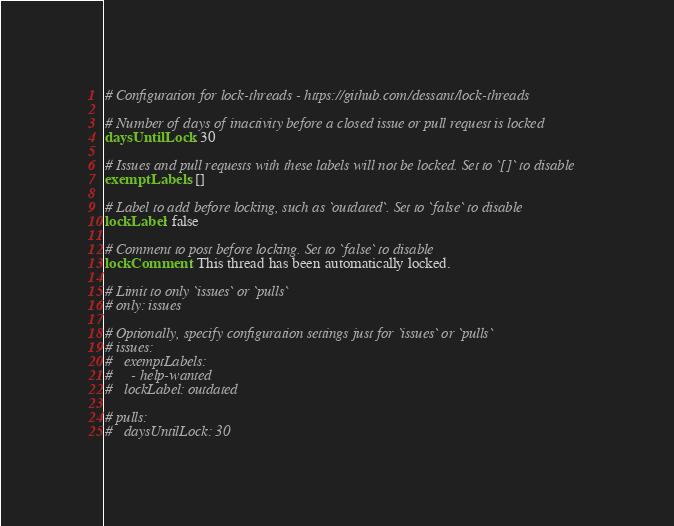Convert code to text. <code><loc_0><loc_0><loc_500><loc_500><_YAML_># Configuration for lock-threads - https://github.com/dessant/lock-threads

# Number of days of inactivity before a closed issue or pull request is locked
daysUntilLock: 30

# Issues and pull requests with these labels will not be locked. Set to `[]` to disable
exemptLabels: []

# Label to add before locking, such as `outdated`. Set to `false` to disable
lockLabel: false

# Comment to post before locking. Set to `false` to disable
lockComment: This thread has been automatically locked.

# Limit to only `issues` or `pulls`
# only: issues

# Optionally, specify configuration settings just for `issues` or `pulls`
# issues:
#   exemptLabels:
#     - help-wanted
#   lockLabel: outdated

# pulls:
#   daysUntilLock: 30
</code> 